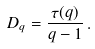Convert formula to latex. <formula><loc_0><loc_0><loc_500><loc_500>D _ { q } = \frac { \tau ( q ) } { q - 1 } \, .</formula> 